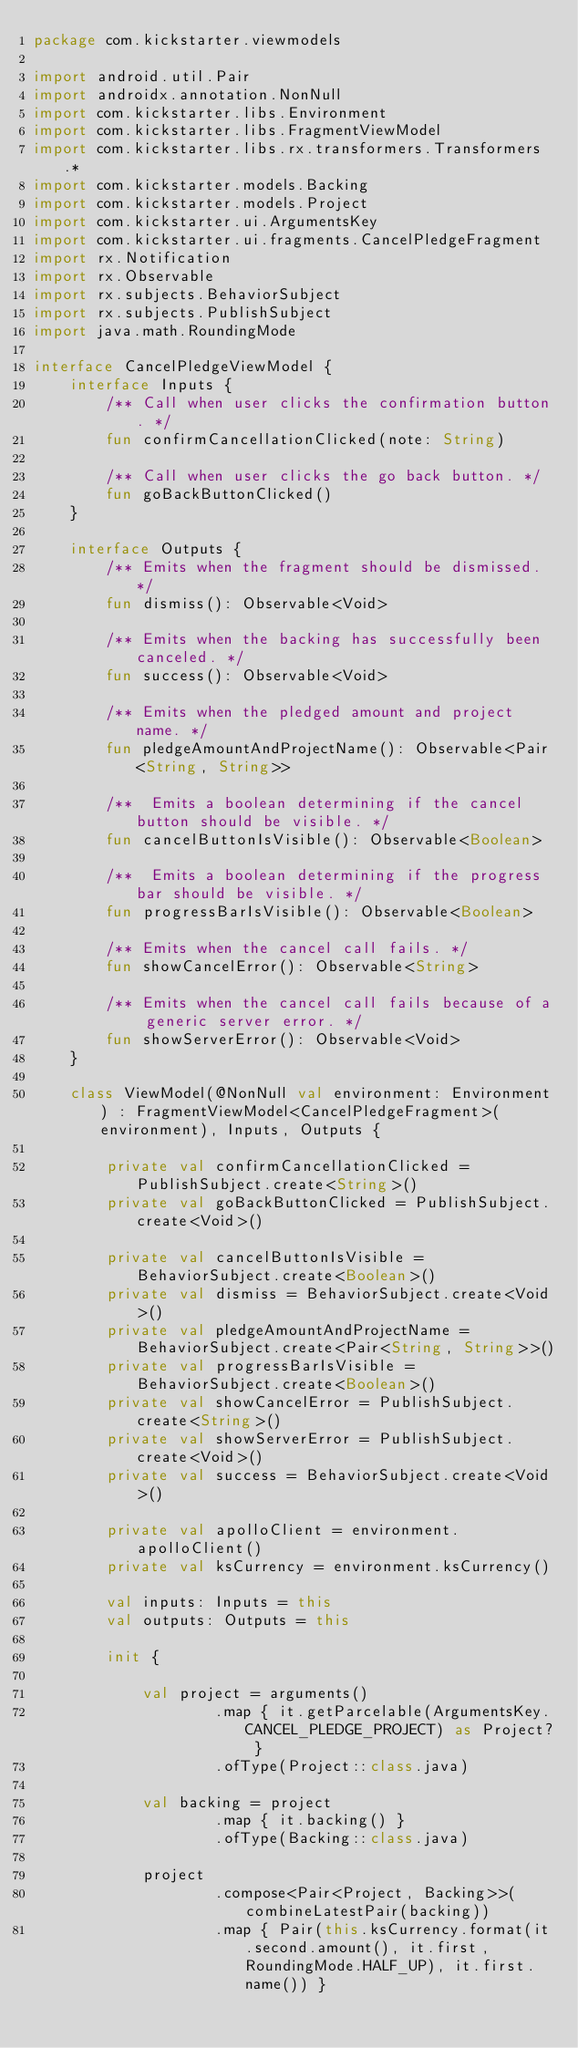<code> <loc_0><loc_0><loc_500><loc_500><_Kotlin_>package com.kickstarter.viewmodels

import android.util.Pair
import androidx.annotation.NonNull
import com.kickstarter.libs.Environment
import com.kickstarter.libs.FragmentViewModel
import com.kickstarter.libs.rx.transformers.Transformers.*
import com.kickstarter.models.Backing
import com.kickstarter.models.Project
import com.kickstarter.ui.ArgumentsKey
import com.kickstarter.ui.fragments.CancelPledgeFragment
import rx.Notification
import rx.Observable
import rx.subjects.BehaviorSubject
import rx.subjects.PublishSubject
import java.math.RoundingMode

interface CancelPledgeViewModel {
    interface Inputs {
        /** Call when user clicks the confirmation button. */
        fun confirmCancellationClicked(note: String)

        /** Call when user clicks the go back button. */
        fun goBackButtonClicked()
    }

    interface Outputs {
        /** Emits when the fragment should be dismissed. */
        fun dismiss(): Observable<Void>

        /** Emits when the backing has successfully been canceled. */
        fun success(): Observable<Void>

        /** Emits when the pledged amount and project name. */
        fun pledgeAmountAndProjectName(): Observable<Pair<String, String>>

        /**  Emits a boolean determining if the cancel button should be visible. */
        fun cancelButtonIsVisible(): Observable<Boolean>

        /**  Emits a boolean determining if the progress bar should be visible. */
        fun progressBarIsVisible(): Observable<Boolean>

        /** Emits when the cancel call fails. */
        fun showCancelError(): Observable<String>

        /** Emits when the cancel call fails because of a generic server error. */
        fun showServerError(): Observable<Void>
    }

    class ViewModel(@NonNull val environment: Environment) : FragmentViewModel<CancelPledgeFragment>(environment), Inputs, Outputs {

        private val confirmCancellationClicked = PublishSubject.create<String>()
        private val goBackButtonClicked = PublishSubject.create<Void>()

        private val cancelButtonIsVisible = BehaviorSubject.create<Boolean>()
        private val dismiss = BehaviorSubject.create<Void>()
        private val pledgeAmountAndProjectName = BehaviorSubject.create<Pair<String, String>>()
        private val progressBarIsVisible = BehaviorSubject.create<Boolean>()
        private val showCancelError = PublishSubject.create<String>()
        private val showServerError = PublishSubject.create<Void>()
        private val success = BehaviorSubject.create<Void>()

        private val apolloClient = environment.apolloClient()
        private val ksCurrency = environment.ksCurrency()

        val inputs: Inputs = this
        val outputs: Outputs = this

        init {

            val project = arguments()
                    .map { it.getParcelable(ArgumentsKey.CANCEL_PLEDGE_PROJECT) as Project? }
                    .ofType(Project::class.java)

            val backing = project
                    .map { it.backing() }
                    .ofType(Backing::class.java)

            project
                    .compose<Pair<Project, Backing>>(combineLatestPair(backing))
                    .map { Pair(this.ksCurrency.format(it.second.amount(), it.first, RoundingMode.HALF_UP), it.first.name()) }</code> 